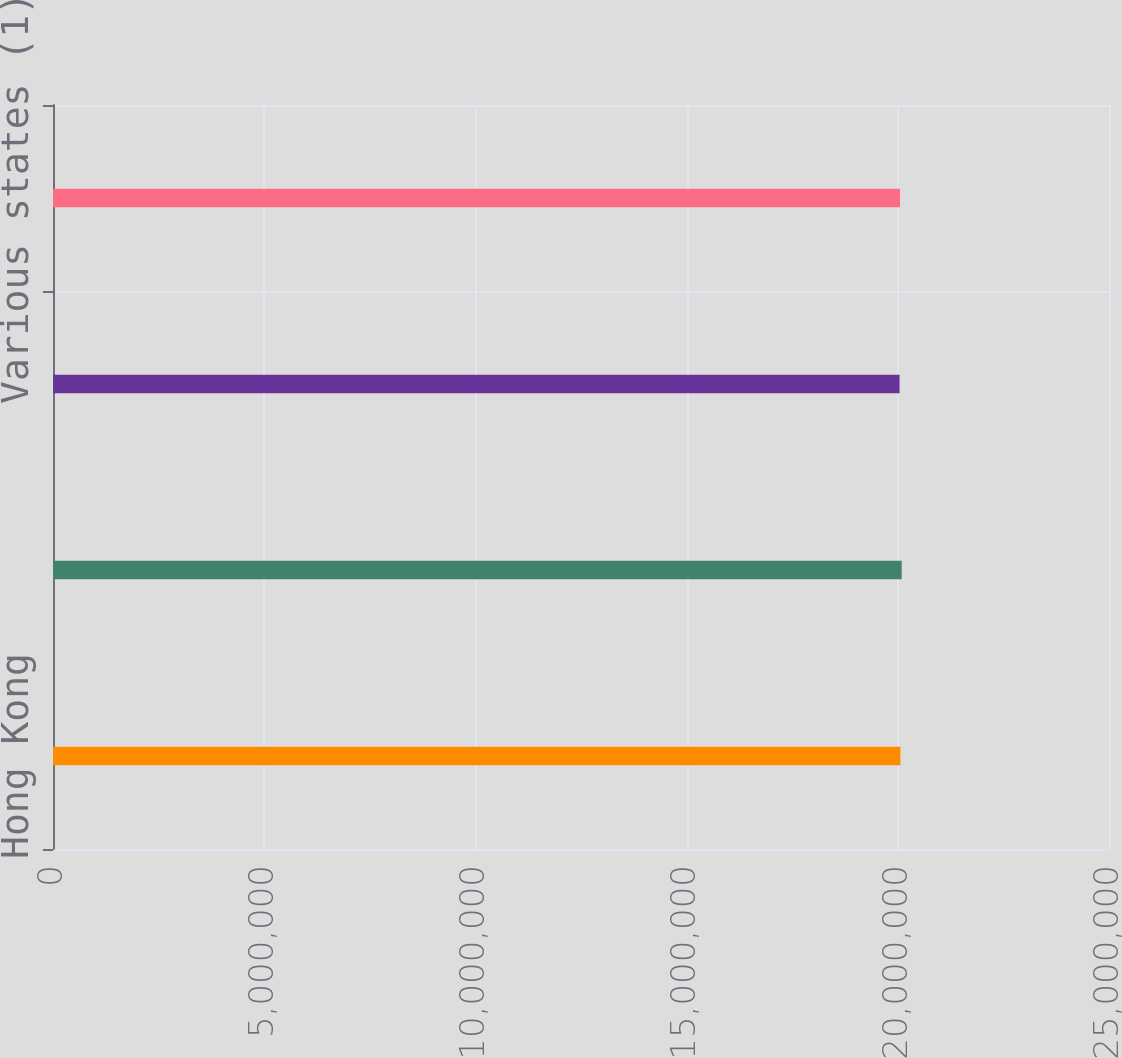Convert chart. <chart><loc_0><loc_0><loc_500><loc_500><bar_chart><fcel>Hong Kong<fcel>United Kingdom<fcel>United States<fcel>Various states (1)<nl><fcel>2.0062e+07<fcel>2.0092e+07<fcel>2.0042e+07<fcel>2.0052e+07<nl></chart> 